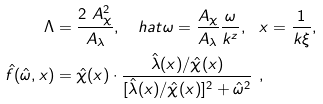Convert formula to latex. <formula><loc_0><loc_0><loc_500><loc_500>\Lambda & = \frac { 2 \ A _ { \chi } ^ { 2 } } { A _ { \lambda } } , \quad h a t { \omega } = \frac { A _ { \chi } } { A _ { \lambda } } \frac { \omega } { k ^ { z } } , \ \ x = \frac { 1 } { k \xi } , \\ \hat { f } ( \hat { \omega } , x ) & = \hat { \chi } ( x ) \cdot \frac { \hat { \lambda } ( x ) / { \hat { \chi } ( x ) } } { [ \hat { \lambda } ( x ) / { \hat { \chi } ( x ) } ] ^ { 2 } + \hat { \omega } ^ { 2 } } \ ,</formula> 